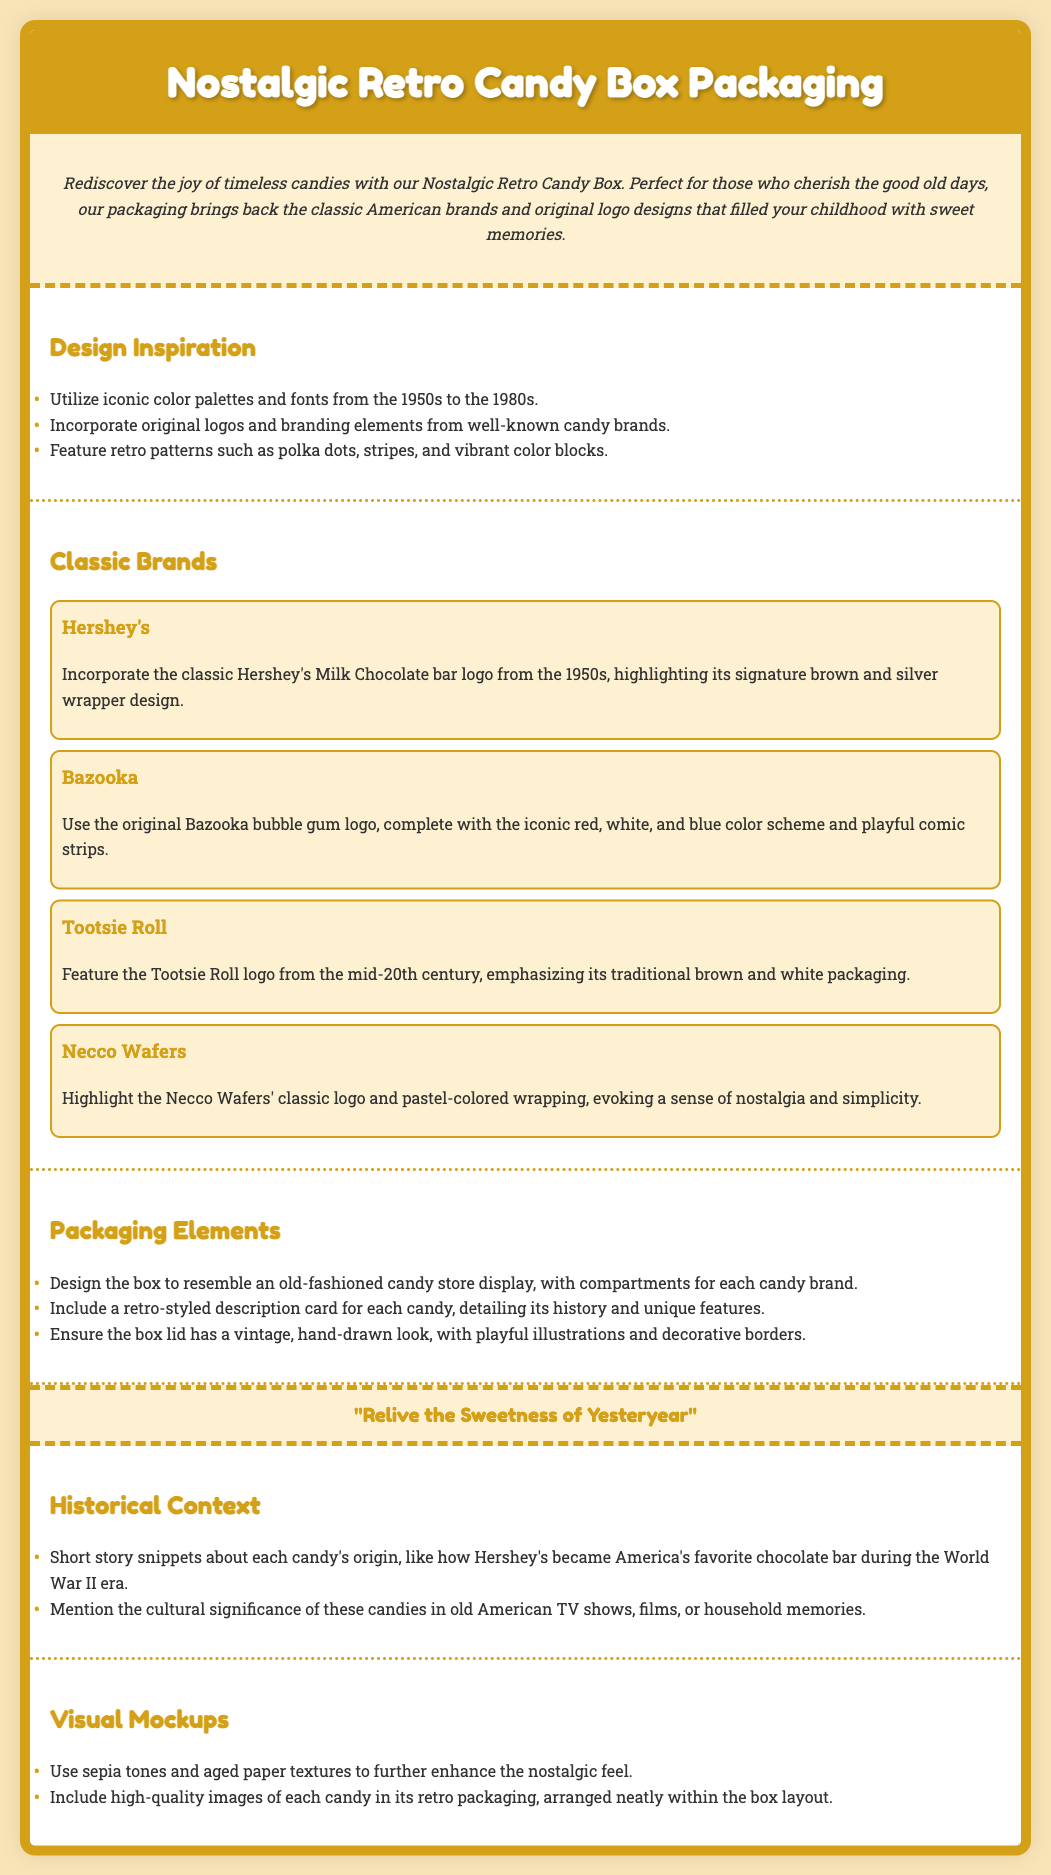What is the title of the document? The title of the document is provided in the header section, which describes the theme of the content.
Answer: Nostalgic Retro Candy Box Packaging How many classic brands are featured? The document details several classic brands within a specific section, listing each one separately.
Answer: Four Which iconic color scheme is used for Bazooka? The document mentions the branding elements of Bazooka, focusing on its distinct color palette.
Answer: Red, white, and blue What is the slogan of the product? The slogan is highlighted in a special section that emphasizes the nostalgic theme of the product.
Answer: Relive the Sweetness of Yesteryear What type of packaging design is suggested? The document specifically describes the packaging design that evokes a classic candy store experience.
Answer: Old-fashioned candy store display Who is mentioned as America's favorite chocolate bar during World War II? The historical context section provides a narrative about the significance of a specific candy during a notable time.
Answer: Hershey's What is the design feature for the box lid? The packaging elements section outlines a specific aesthetic for the box lid that adds to its vintage feel.
Answer: Vintage, hand-drawn look What kind of tones and textures are recommended for visual mockups? The visual mockups section includes details about how to enhance the nostalgic appeal visually.
Answer: Sepia tones and aged paper textures 